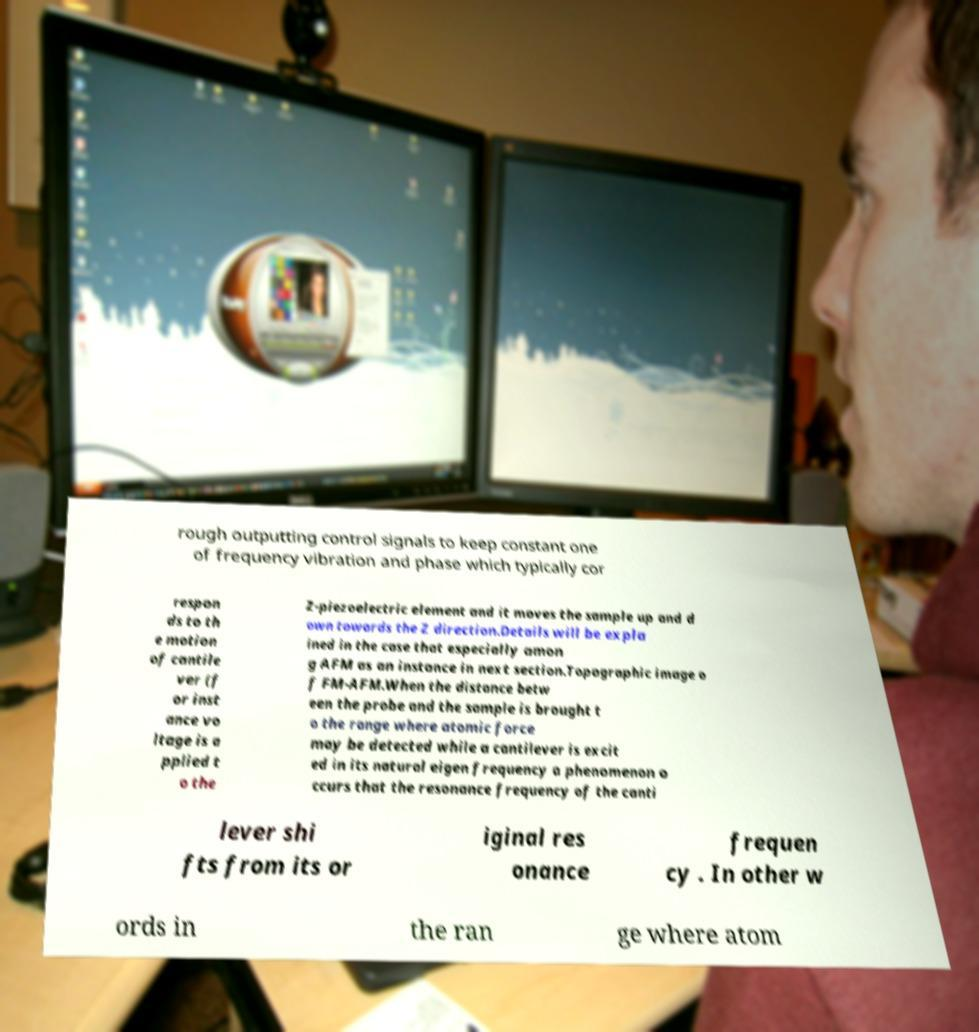Can you accurately transcribe the text from the provided image for me? rough outputting control signals to keep constant one of frequency vibration and phase which typically cor respon ds to th e motion of cantile ver (f or inst ance vo ltage is a pplied t o the Z-piezoelectric element and it moves the sample up and d own towards the Z direction.Details will be expla ined in the case that especially amon g AFM as an instance in next section.Topographic image o f FM-AFM.When the distance betw een the probe and the sample is brought t o the range where atomic force may be detected while a cantilever is excit ed in its natural eigen frequency a phenomenon o ccurs that the resonance frequency of the canti lever shi fts from its or iginal res onance frequen cy . In other w ords in the ran ge where atom 